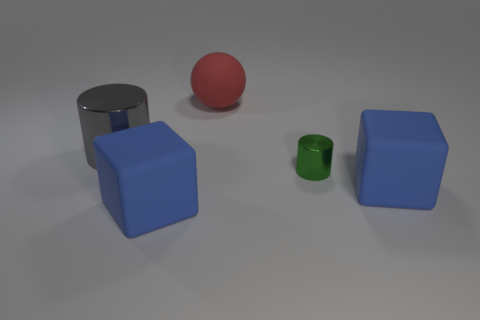Do the green thing and the red matte thing right of the gray object have the same shape? No, they do not have the same shape. The green object appears to be a small cylinder, while the red object is a sphere. 